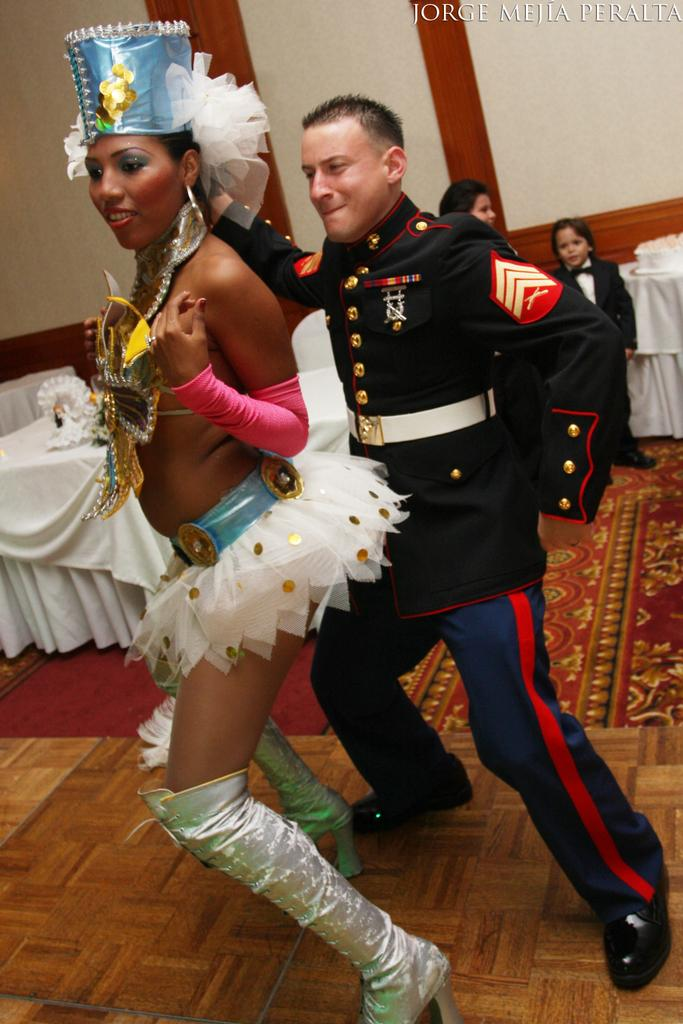Who is present in the image? There is a man and a woman in the image. What are the man and woman doing in the image? The man and woman are dancing in the image. Where are they dancing? They are dancing on the floor. What can be seen in the background of the image? There are tables, persons, and a wall in the background of the image. What type of eggnog is being served at the table in the image? There is no eggnog present in the image; it only features a man and a woman dancing on the floor. How does the man stretch his arms while dancing in the image? The image does not show the man stretching his arms while dancing; it only shows him dancing with the woman. 